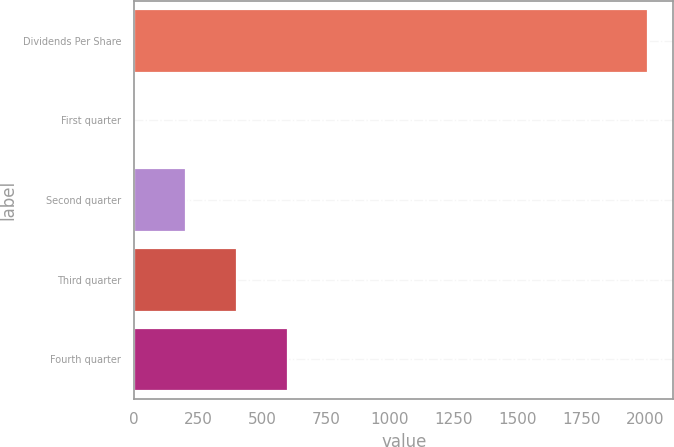<chart> <loc_0><loc_0><loc_500><loc_500><bar_chart><fcel>Dividends Per Share<fcel>First quarter<fcel>Second quarter<fcel>Third quarter<fcel>Fourth quarter<nl><fcel>2009<fcel>0.24<fcel>201.12<fcel>402<fcel>602.88<nl></chart> 